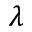Convert formula to latex. <formula><loc_0><loc_0><loc_500><loc_500>\lambda</formula> 